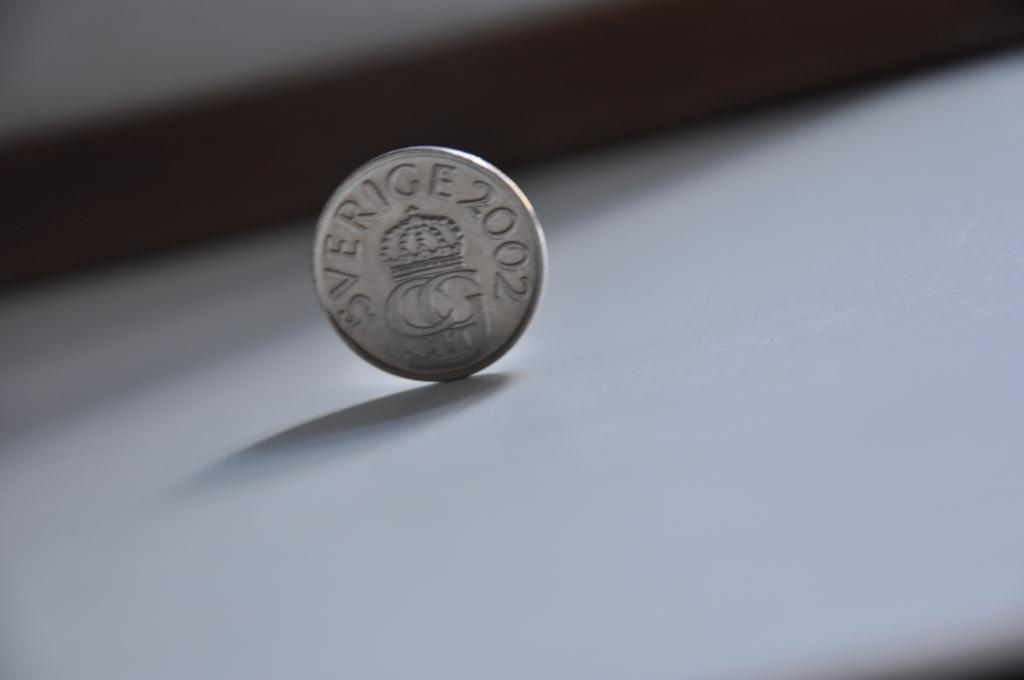<image>
Give a short and clear explanation of the subsequent image. A silver coin with the number 2002 on it. 